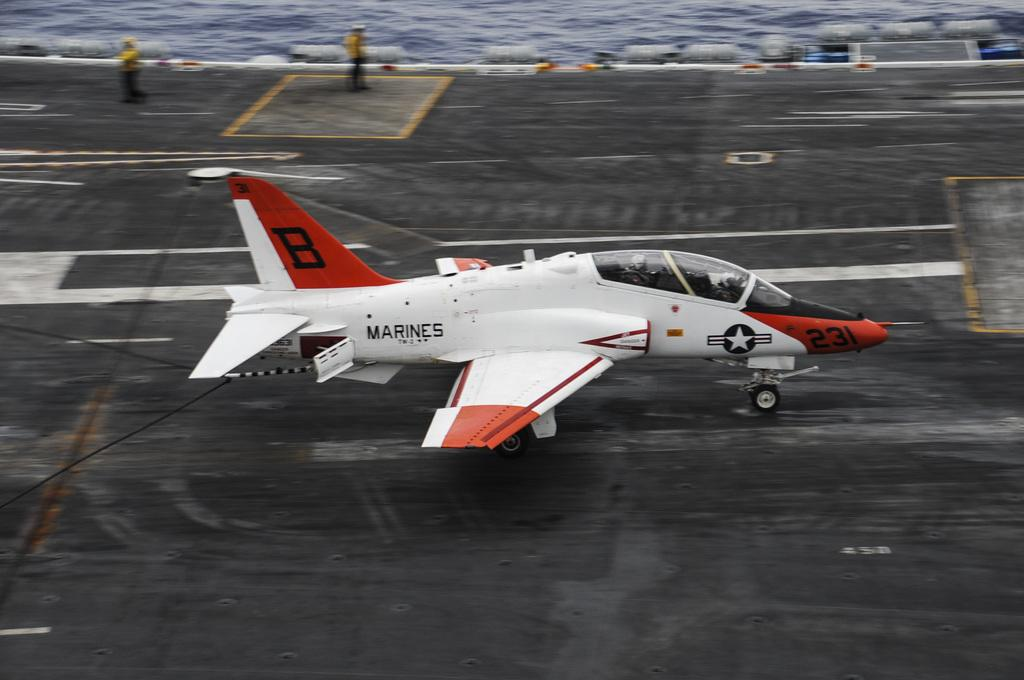What is the main subject in the foreground of the image? There is a jet plane in the foreground of the image. What is the jet plane doing in the image? The jet plane is moving on the runway. What natural element can be seen in the image? There is water visible in the image. What sense is being evoked by the railway in the image? There is no railway present in the image, so it is not possible to answer a question about a sense being evoked by it. 